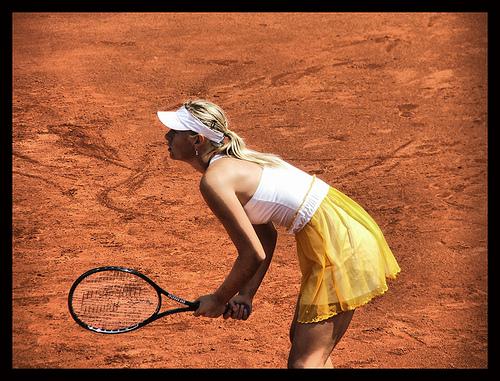What is the yellow material of her skirt?
Short answer required. Chiffon. What tennis player is this?
Be succinct. Maria sharapova. What is the color of the visor?
Quick response, please. White. 